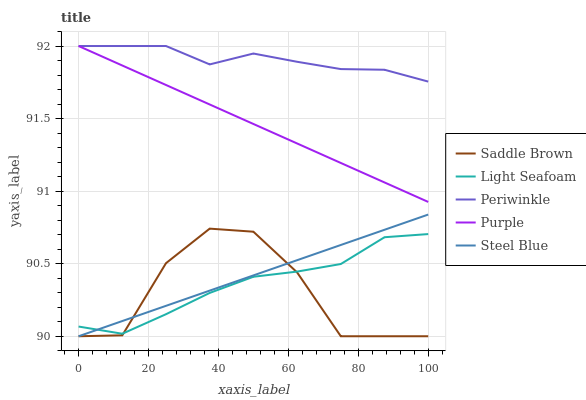Does Saddle Brown have the minimum area under the curve?
Answer yes or no. Yes. Does Periwinkle have the maximum area under the curve?
Answer yes or no. Yes. Does Light Seafoam have the minimum area under the curve?
Answer yes or no. No. Does Light Seafoam have the maximum area under the curve?
Answer yes or no. No. Is Purple the smoothest?
Answer yes or no. Yes. Is Saddle Brown the roughest?
Answer yes or no. Yes. Is Light Seafoam the smoothest?
Answer yes or no. No. Is Light Seafoam the roughest?
Answer yes or no. No. Does Light Seafoam have the lowest value?
Answer yes or no. No. Does Periwinkle have the highest value?
Answer yes or no. Yes. Does Light Seafoam have the highest value?
Answer yes or no. No. Is Light Seafoam less than Purple?
Answer yes or no. Yes. Is Purple greater than Steel Blue?
Answer yes or no. Yes. Does Steel Blue intersect Light Seafoam?
Answer yes or no. Yes. Is Steel Blue less than Light Seafoam?
Answer yes or no. No. Is Steel Blue greater than Light Seafoam?
Answer yes or no. No. Does Light Seafoam intersect Purple?
Answer yes or no. No. 